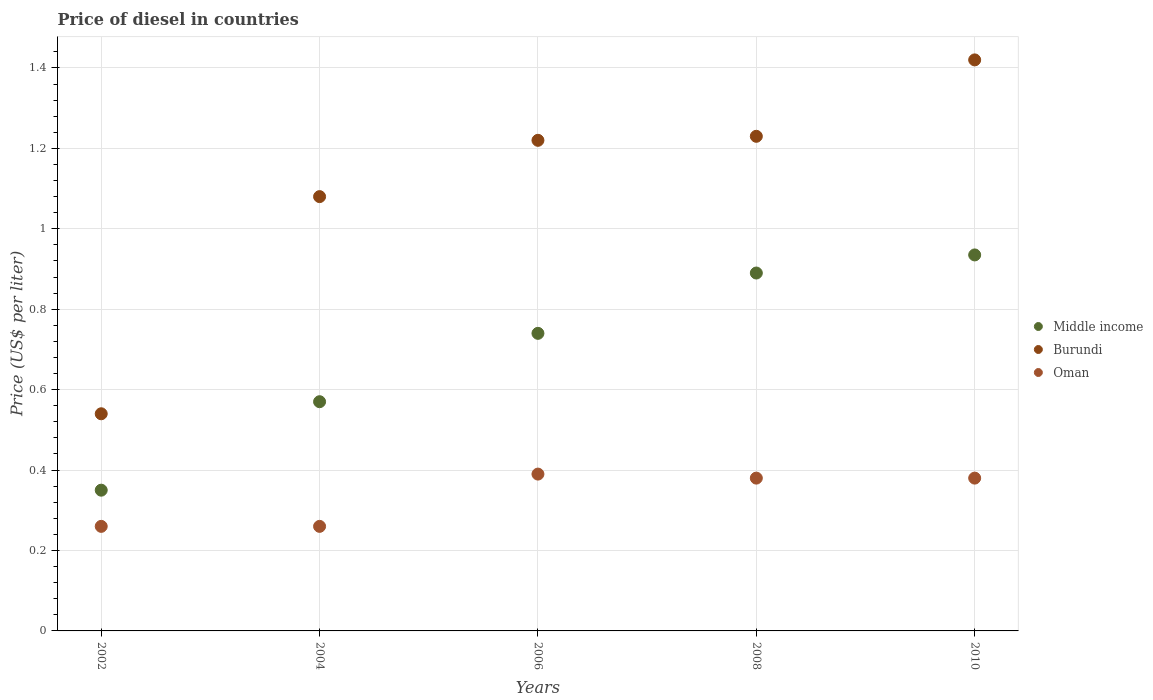How many different coloured dotlines are there?
Provide a succinct answer. 3. Is the number of dotlines equal to the number of legend labels?
Give a very brief answer. Yes. What is the price of diesel in Middle income in 2006?
Make the answer very short. 0.74. Across all years, what is the maximum price of diesel in Middle income?
Make the answer very short. 0.94. Across all years, what is the minimum price of diesel in Burundi?
Provide a short and direct response. 0.54. In which year was the price of diesel in Oman maximum?
Offer a terse response. 2006. In which year was the price of diesel in Oman minimum?
Offer a very short reply. 2002. What is the total price of diesel in Oman in the graph?
Your response must be concise. 1.67. What is the difference between the price of diesel in Burundi in 2008 and that in 2010?
Ensure brevity in your answer.  -0.19. What is the difference between the price of diesel in Burundi in 2004 and the price of diesel in Oman in 2010?
Your answer should be very brief. 0.7. What is the average price of diesel in Oman per year?
Make the answer very short. 0.33. What is the ratio of the price of diesel in Burundi in 2002 to that in 2008?
Your response must be concise. 0.44. What is the difference between the highest and the second highest price of diesel in Oman?
Provide a short and direct response. 0.01. What is the difference between the highest and the lowest price of diesel in Middle income?
Provide a succinct answer. 0.59. In how many years, is the price of diesel in Middle income greater than the average price of diesel in Middle income taken over all years?
Offer a terse response. 3. Is it the case that in every year, the sum of the price of diesel in Burundi and price of diesel in Middle income  is greater than the price of diesel in Oman?
Ensure brevity in your answer.  Yes. How many dotlines are there?
Offer a very short reply. 3. What is the difference between two consecutive major ticks on the Y-axis?
Offer a very short reply. 0.2. Does the graph contain grids?
Make the answer very short. Yes. What is the title of the graph?
Provide a succinct answer. Price of diesel in countries. Does "Samoa" appear as one of the legend labels in the graph?
Make the answer very short. No. What is the label or title of the Y-axis?
Make the answer very short. Price (US$ per liter). What is the Price (US$ per liter) in Burundi in 2002?
Your response must be concise. 0.54. What is the Price (US$ per liter) in Oman in 2002?
Provide a succinct answer. 0.26. What is the Price (US$ per liter) of Middle income in 2004?
Ensure brevity in your answer.  0.57. What is the Price (US$ per liter) in Oman in 2004?
Provide a short and direct response. 0.26. What is the Price (US$ per liter) in Middle income in 2006?
Make the answer very short. 0.74. What is the Price (US$ per liter) of Burundi in 2006?
Keep it short and to the point. 1.22. What is the Price (US$ per liter) of Oman in 2006?
Your response must be concise. 0.39. What is the Price (US$ per liter) in Middle income in 2008?
Provide a short and direct response. 0.89. What is the Price (US$ per liter) in Burundi in 2008?
Provide a succinct answer. 1.23. What is the Price (US$ per liter) in Oman in 2008?
Offer a terse response. 0.38. What is the Price (US$ per liter) of Middle income in 2010?
Your answer should be compact. 0.94. What is the Price (US$ per liter) in Burundi in 2010?
Your response must be concise. 1.42. What is the Price (US$ per liter) of Oman in 2010?
Give a very brief answer. 0.38. Across all years, what is the maximum Price (US$ per liter) in Middle income?
Offer a very short reply. 0.94. Across all years, what is the maximum Price (US$ per liter) in Burundi?
Give a very brief answer. 1.42. Across all years, what is the maximum Price (US$ per liter) in Oman?
Your answer should be very brief. 0.39. Across all years, what is the minimum Price (US$ per liter) in Burundi?
Your answer should be compact. 0.54. Across all years, what is the minimum Price (US$ per liter) in Oman?
Provide a short and direct response. 0.26. What is the total Price (US$ per liter) of Middle income in the graph?
Ensure brevity in your answer.  3.48. What is the total Price (US$ per liter) of Burundi in the graph?
Make the answer very short. 5.49. What is the total Price (US$ per liter) in Oman in the graph?
Provide a short and direct response. 1.67. What is the difference between the Price (US$ per liter) of Middle income in 2002 and that in 2004?
Ensure brevity in your answer.  -0.22. What is the difference between the Price (US$ per liter) in Burundi in 2002 and that in 2004?
Offer a terse response. -0.54. What is the difference between the Price (US$ per liter) in Middle income in 2002 and that in 2006?
Offer a very short reply. -0.39. What is the difference between the Price (US$ per liter) in Burundi in 2002 and that in 2006?
Give a very brief answer. -0.68. What is the difference between the Price (US$ per liter) in Oman in 2002 and that in 2006?
Offer a terse response. -0.13. What is the difference between the Price (US$ per liter) in Middle income in 2002 and that in 2008?
Offer a terse response. -0.54. What is the difference between the Price (US$ per liter) of Burundi in 2002 and that in 2008?
Provide a succinct answer. -0.69. What is the difference between the Price (US$ per liter) of Oman in 2002 and that in 2008?
Provide a short and direct response. -0.12. What is the difference between the Price (US$ per liter) in Middle income in 2002 and that in 2010?
Make the answer very short. -0.58. What is the difference between the Price (US$ per liter) in Burundi in 2002 and that in 2010?
Ensure brevity in your answer.  -0.88. What is the difference between the Price (US$ per liter) in Oman in 2002 and that in 2010?
Ensure brevity in your answer.  -0.12. What is the difference between the Price (US$ per liter) in Middle income in 2004 and that in 2006?
Your response must be concise. -0.17. What is the difference between the Price (US$ per liter) in Burundi in 2004 and that in 2006?
Ensure brevity in your answer.  -0.14. What is the difference between the Price (US$ per liter) of Oman in 2004 and that in 2006?
Your answer should be compact. -0.13. What is the difference between the Price (US$ per liter) in Middle income in 2004 and that in 2008?
Keep it short and to the point. -0.32. What is the difference between the Price (US$ per liter) of Burundi in 2004 and that in 2008?
Ensure brevity in your answer.  -0.15. What is the difference between the Price (US$ per liter) in Oman in 2004 and that in 2008?
Your answer should be compact. -0.12. What is the difference between the Price (US$ per liter) of Middle income in 2004 and that in 2010?
Offer a terse response. -0.36. What is the difference between the Price (US$ per liter) of Burundi in 2004 and that in 2010?
Provide a short and direct response. -0.34. What is the difference between the Price (US$ per liter) of Oman in 2004 and that in 2010?
Ensure brevity in your answer.  -0.12. What is the difference between the Price (US$ per liter) of Middle income in 2006 and that in 2008?
Give a very brief answer. -0.15. What is the difference between the Price (US$ per liter) of Burundi in 2006 and that in 2008?
Provide a short and direct response. -0.01. What is the difference between the Price (US$ per liter) in Oman in 2006 and that in 2008?
Give a very brief answer. 0.01. What is the difference between the Price (US$ per liter) in Middle income in 2006 and that in 2010?
Offer a very short reply. -0.2. What is the difference between the Price (US$ per liter) in Burundi in 2006 and that in 2010?
Provide a succinct answer. -0.2. What is the difference between the Price (US$ per liter) of Oman in 2006 and that in 2010?
Give a very brief answer. 0.01. What is the difference between the Price (US$ per liter) of Middle income in 2008 and that in 2010?
Your answer should be compact. -0.04. What is the difference between the Price (US$ per liter) in Burundi in 2008 and that in 2010?
Your response must be concise. -0.19. What is the difference between the Price (US$ per liter) of Middle income in 2002 and the Price (US$ per liter) of Burundi in 2004?
Ensure brevity in your answer.  -0.73. What is the difference between the Price (US$ per liter) in Middle income in 2002 and the Price (US$ per liter) in Oman in 2004?
Ensure brevity in your answer.  0.09. What is the difference between the Price (US$ per liter) in Burundi in 2002 and the Price (US$ per liter) in Oman in 2004?
Make the answer very short. 0.28. What is the difference between the Price (US$ per liter) of Middle income in 2002 and the Price (US$ per liter) of Burundi in 2006?
Keep it short and to the point. -0.87. What is the difference between the Price (US$ per liter) of Middle income in 2002 and the Price (US$ per liter) of Oman in 2006?
Your answer should be compact. -0.04. What is the difference between the Price (US$ per liter) of Middle income in 2002 and the Price (US$ per liter) of Burundi in 2008?
Keep it short and to the point. -0.88. What is the difference between the Price (US$ per liter) in Middle income in 2002 and the Price (US$ per liter) in Oman in 2008?
Keep it short and to the point. -0.03. What is the difference between the Price (US$ per liter) in Burundi in 2002 and the Price (US$ per liter) in Oman in 2008?
Your answer should be compact. 0.16. What is the difference between the Price (US$ per liter) in Middle income in 2002 and the Price (US$ per liter) in Burundi in 2010?
Keep it short and to the point. -1.07. What is the difference between the Price (US$ per liter) of Middle income in 2002 and the Price (US$ per liter) of Oman in 2010?
Give a very brief answer. -0.03. What is the difference between the Price (US$ per liter) of Burundi in 2002 and the Price (US$ per liter) of Oman in 2010?
Keep it short and to the point. 0.16. What is the difference between the Price (US$ per liter) of Middle income in 2004 and the Price (US$ per liter) of Burundi in 2006?
Your answer should be compact. -0.65. What is the difference between the Price (US$ per liter) of Middle income in 2004 and the Price (US$ per liter) of Oman in 2006?
Provide a succinct answer. 0.18. What is the difference between the Price (US$ per liter) in Burundi in 2004 and the Price (US$ per liter) in Oman in 2006?
Give a very brief answer. 0.69. What is the difference between the Price (US$ per liter) of Middle income in 2004 and the Price (US$ per liter) of Burundi in 2008?
Make the answer very short. -0.66. What is the difference between the Price (US$ per liter) of Middle income in 2004 and the Price (US$ per liter) of Oman in 2008?
Your answer should be compact. 0.19. What is the difference between the Price (US$ per liter) in Middle income in 2004 and the Price (US$ per liter) in Burundi in 2010?
Your answer should be compact. -0.85. What is the difference between the Price (US$ per liter) of Middle income in 2004 and the Price (US$ per liter) of Oman in 2010?
Your answer should be compact. 0.19. What is the difference between the Price (US$ per liter) of Middle income in 2006 and the Price (US$ per liter) of Burundi in 2008?
Your answer should be compact. -0.49. What is the difference between the Price (US$ per liter) in Middle income in 2006 and the Price (US$ per liter) in Oman in 2008?
Your answer should be compact. 0.36. What is the difference between the Price (US$ per liter) of Burundi in 2006 and the Price (US$ per liter) of Oman in 2008?
Your answer should be compact. 0.84. What is the difference between the Price (US$ per liter) of Middle income in 2006 and the Price (US$ per liter) of Burundi in 2010?
Offer a very short reply. -0.68. What is the difference between the Price (US$ per liter) of Middle income in 2006 and the Price (US$ per liter) of Oman in 2010?
Give a very brief answer. 0.36. What is the difference between the Price (US$ per liter) in Burundi in 2006 and the Price (US$ per liter) in Oman in 2010?
Provide a succinct answer. 0.84. What is the difference between the Price (US$ per liter) in Middle income in 2008 and the Price (US$ per liter) in Burundi in 2010?
Keep it short and to the point. -0.53. What is the difference between the Price (US$ per liter) in Middle income in 2008 and the Price (US$ per liter) in Oman in 2010?
Make the answer very short. 0.51. What is the average Price (US$ per liter) of Middle income per year?
Make the answer very short. 0.7. What is the average Price (US$ per liter) in Burundi per year?
Your answer should be very brief. 1.1. What is the average Price (US$ per liter) of Oman per year?
Provide a succinct answer. 0.33. In the year 2002, what is the difference between the Price (US$ per liter) of Middle income and Price (US$ per liter) of Burundi?
Keep it short and to the point. -0.19. In the year 2002, what is the difference between the Price (US$ per liter) in Middle income and Price (US$ per liter) in Oman?
Provide a short and direct response. 0.09. In the year 2002, what is the difference between the Price (US$ per liter) in Burundi and Price (US$ per liter) in Oman?
Your answer should be compact. 0.28. In the year 2004, what is the difference between the Price (US$ per liter) in Middle income and Price (US$ per liter) in Burundi?
Keep it short and to the point. -0.51. In the year 2004, what is the difference between the Price (US$ per liter) of Middle income and Price (US$ per liter) of Oman?
Provide a succinct answer. 0.31. In the year 2004, what is the difference between the Price (US$ per liter) in Burundi and Price (US$ per liter) in Oman?
Provide a short and direct response. 0.82. In the year 2006, what is the difference between the Price (US$ per liter) of Middle income and Price (US$ per liter) of Burundi?
Keep it short and to the point. -0.48. In the year 2006, what is the difference between the Price (US$ per liter) in Middle income and Price (US$ per liter) in Oman?
Offer a terse response. 0.35. In the year 2006, what is the difference between the Price (US$ per liter) in Burundi and Price (US$ per liter) in Oman?
Make the answer very short. 0.83. In the year 2008, what is the difference between the Price (US$ per liter) of Middle income and Price (US$ per liter) of Burundi?
Ensure brevity in your answer.  -0.34. In the year 2008, what is the difference between the Price (US$ per liter) of Middle income and Price (US$ per liter) of Oman?
Your answer should be compact. 0.51. In the year 2008, what is the difference between the Price (US$ per liter) in Burundi and Price (US$ per liter) in Oman?
Your response must be concise. 0.85. In the year 2010, what is the difference between the Price (US$ per liter) of Middle income and Price (US$ per liter) of Burundi?
Offer a very short reply. -0.48. In the year 2010, what is the difference between the Price (US$ per liter) in Middle income and Price (US$ per liter) in Oman?
Give a very brief answer. 0.56. What is the ratio of the Price (US$ per liter) of Middle income in 2002 to that in 2004?
Your answer should be very brief. 0.61. What is the ratio of the Price (US$ per liter) in Burundi in 2002 to that in 2004?
Provide a short and direct response. 0.5. What is the ratio of the Price (US$ per liter) in Oman in 2002 to that in 2004?
Your answer should be very brief. 1. What is the ratio of the Price (US$ per liter) in Middle income in 2002 to that in 2006?
Keep it short and to the point. 0.47. What is the ratio of the Price (US$ per liter) of Burundi in 2002 to that in 2006?
Your answer should be compact. 0.44. What is the ratio of the Price (US$ per liter) of Middle income in 2002 to that in 2008?
Make the answer very short. 0.39. What is the ratio of the Price (US$ per liter) of Burundi in 2002 to that in 2008?
Offer a very short reply. 0.44. What is the ratio of the Price (US$ per liter) of Oman in 2002 to that in 2008?
Offer a very short reply. 0.68. What is the ratio of the Price (US$ per liter) of Middle income in 2002 to that in 2010?
Make the answer very short. 0.37. What is the ratio of the Price (US$ per liter) in Burundi in 2002 to that in 2010?
Keep it short and to the point. 0.38. What is the ratio of the Price (US$ per liter) of Oman in 2002 to that in 2010?
Provide a succinct answer. 0.68. What is the ratio of the Price (US$ per liter) in Middle income in 2004 to that in 2006?
Provide a succinct answer. 0.77. What is the ratio of the Price (US$ per liter) in Burundi in 2004 to that in 2006?
Ensure brevity in your answer.  0.89. What is the ratio of the Price (US$ per liter) of Oman in 2004 to that in 2006?
Ensure brevity in your answer.  0.67. What is the ratio of the Price (US$ per liter) in Middle income in 2004 to that in 2008?
Provide a succinct answer. 0.64. What is the ratio of the Price (US$ per liter) in Burundi in 2004 to that in 2008?
Offer a very short reply. 0.88. What is the ratio of the Price (US$ per liter) in Oman in 2004 to that in 2008?
Your answer should be very brief. 0.68. What is the ratio of the Price (US$ per liter) of Middle income in 2004 to that in 2010?
Your response must be concise. 0.61. What is the ratio of the Price (US$ per liter) of Burundi in 2004 to that in 2010?
Give a very brief answer. 0.76. What is the ratio of the Price (US$ per liter) of Oman in 2004 to that in 2010?
Give a very brief answer. 0.68. What is the ratio of the Price (US$ per liter) of Middle income in 2006 to that in 2008?
Offer a terse response. 0.83. What is the ratio of the Price (US$ per liter) in Burundi in 2006 to that in 2008?
Your answer should be very brief. 0.99. What is the ratio of the Price (US$ per liter) in Oman in 2006 to that in 2008?
Keep it short and to the point. 1.03. What is the ratio of the Price (US$ per liter) of Middle income in 2006 to that in 2010?
Provide a short and direct response. 0.79. What is the ratio of the Price (US$ per liter) in Burundi in 2006 to that in 2010?
Give a very brief answer. 0.86. What is the ratio of the Price (US$ per liter) of Oman in 2006 to that in 2010?
Offer a very short reply. 1.03. What is the ratio of the Price (US$ per liter) in Middle income in 2008 to that in 2010?
Offer a terse response. 0.95. What is the ratio of the Price (US$ per liter) of Burundi in 2008 to that in 2010?
Your response must be concise. 0.87. What is the difference between the highest and the second highest Price (US$ per liter) in Middle income?
Your answer should be very brief. 0.04. What is the difference between the highest and the second highest Price (US$ per liter) of Burundi?
Ensure brevity in your answer.  0.19. What is the difference between the highest and the second highest Price (US$ per liter) in Oman?
Give a very brief answer. 0.01. What is the difference between the highest and the lowest Price (US$ per liter) in Middle income?
Your response must be concise. 0.58. What is the difference between the highest and the lowest Price (US$ per liter) of Oman?
Offer a very short reply. 0.13. 